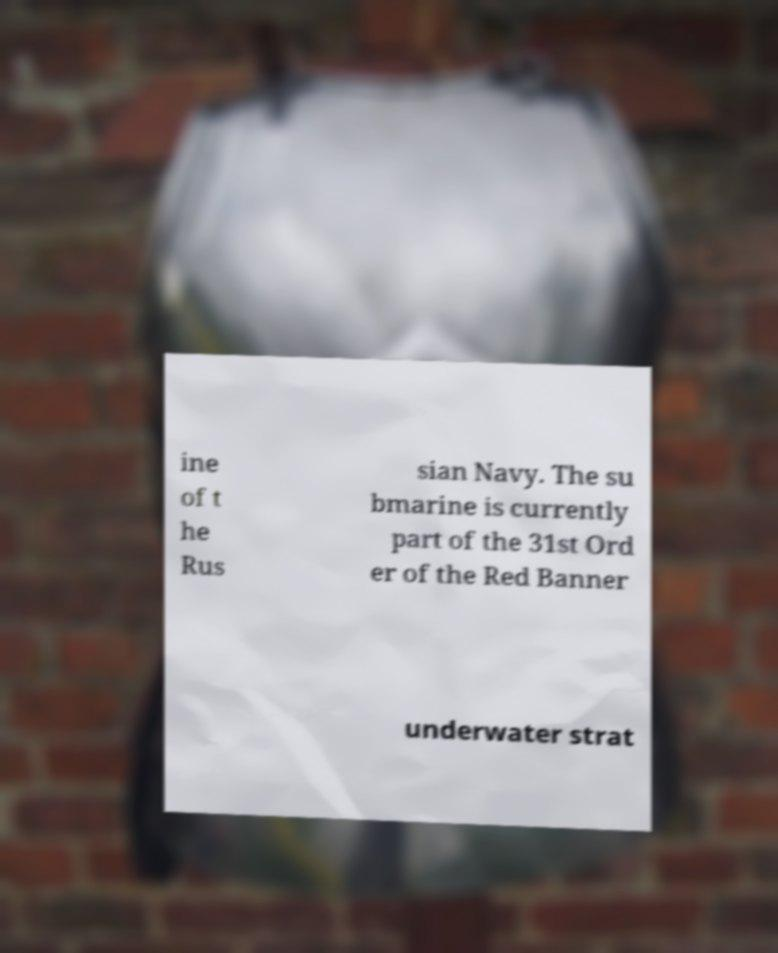Can you accurately transcribe the text from the provided image for me? ine of t he Rus sian Navy. The su bmarine is currently part of the 31st Ord er of the Red Banner underwater strat 